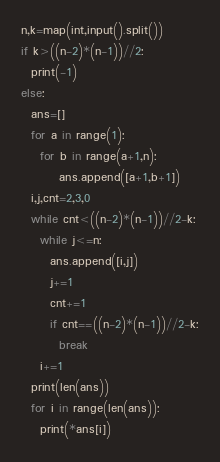Convert code to text. <code><loc_0><loc_0><loc_500><loc_500><_Python_>n,k=map(int,input().split())
if k>((n-2)*(n-1))//2:
  print(-1)
else:
  ans=[]
  for a in range(1):
    for b in range(a+1,n):
        ans.append([a+1,b+1])
  i,j,cnt=2,3,0
  while cnt<((n-2)*(n-1))//2-k:
    while j<=n:
      ans.append([i,j])
      j+=1
      cnt+=1
      if cnt==((n-2)*(n-1))//2-k:
        break
    i+=1
  print(len(ans))
  for i in range(len(ans)):
    print(*ans[i])</code> 